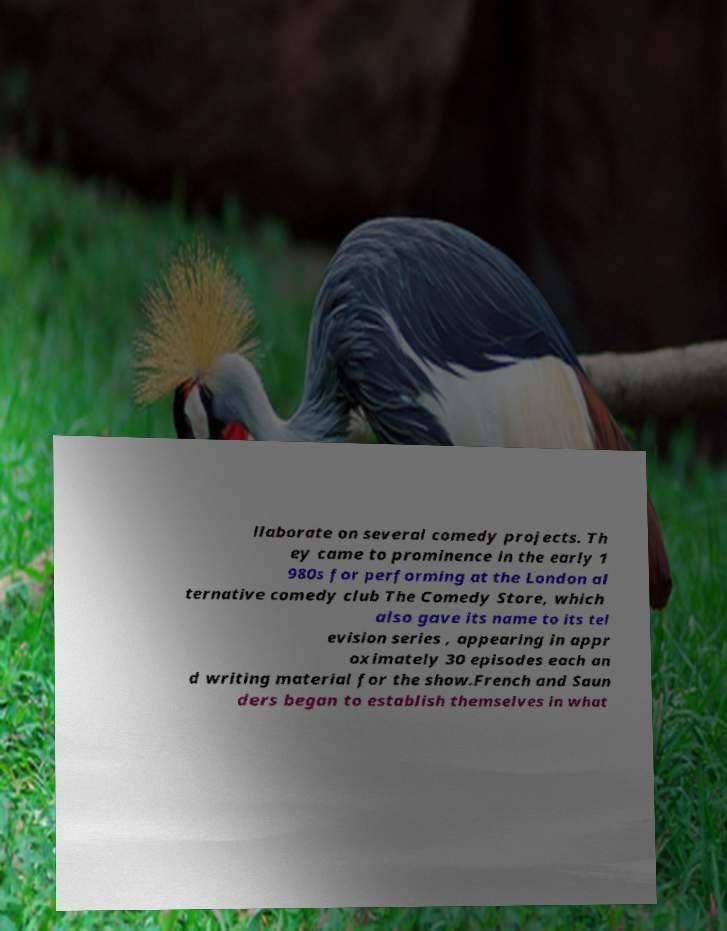Can you read and provide the text displayed in the image?This photo seems to have some interesting text. Can you extract and type it out for me? llaborate on several comedy projects. Th ey came to prominence in the early 1 980s for performing at the London al ternative comedy club The Comedy Store, which also gave its name to its tel evision series , appearing in appr oximately 30 episodes each an d writing material for the show.French and Saun ders began to establish themselves in what 